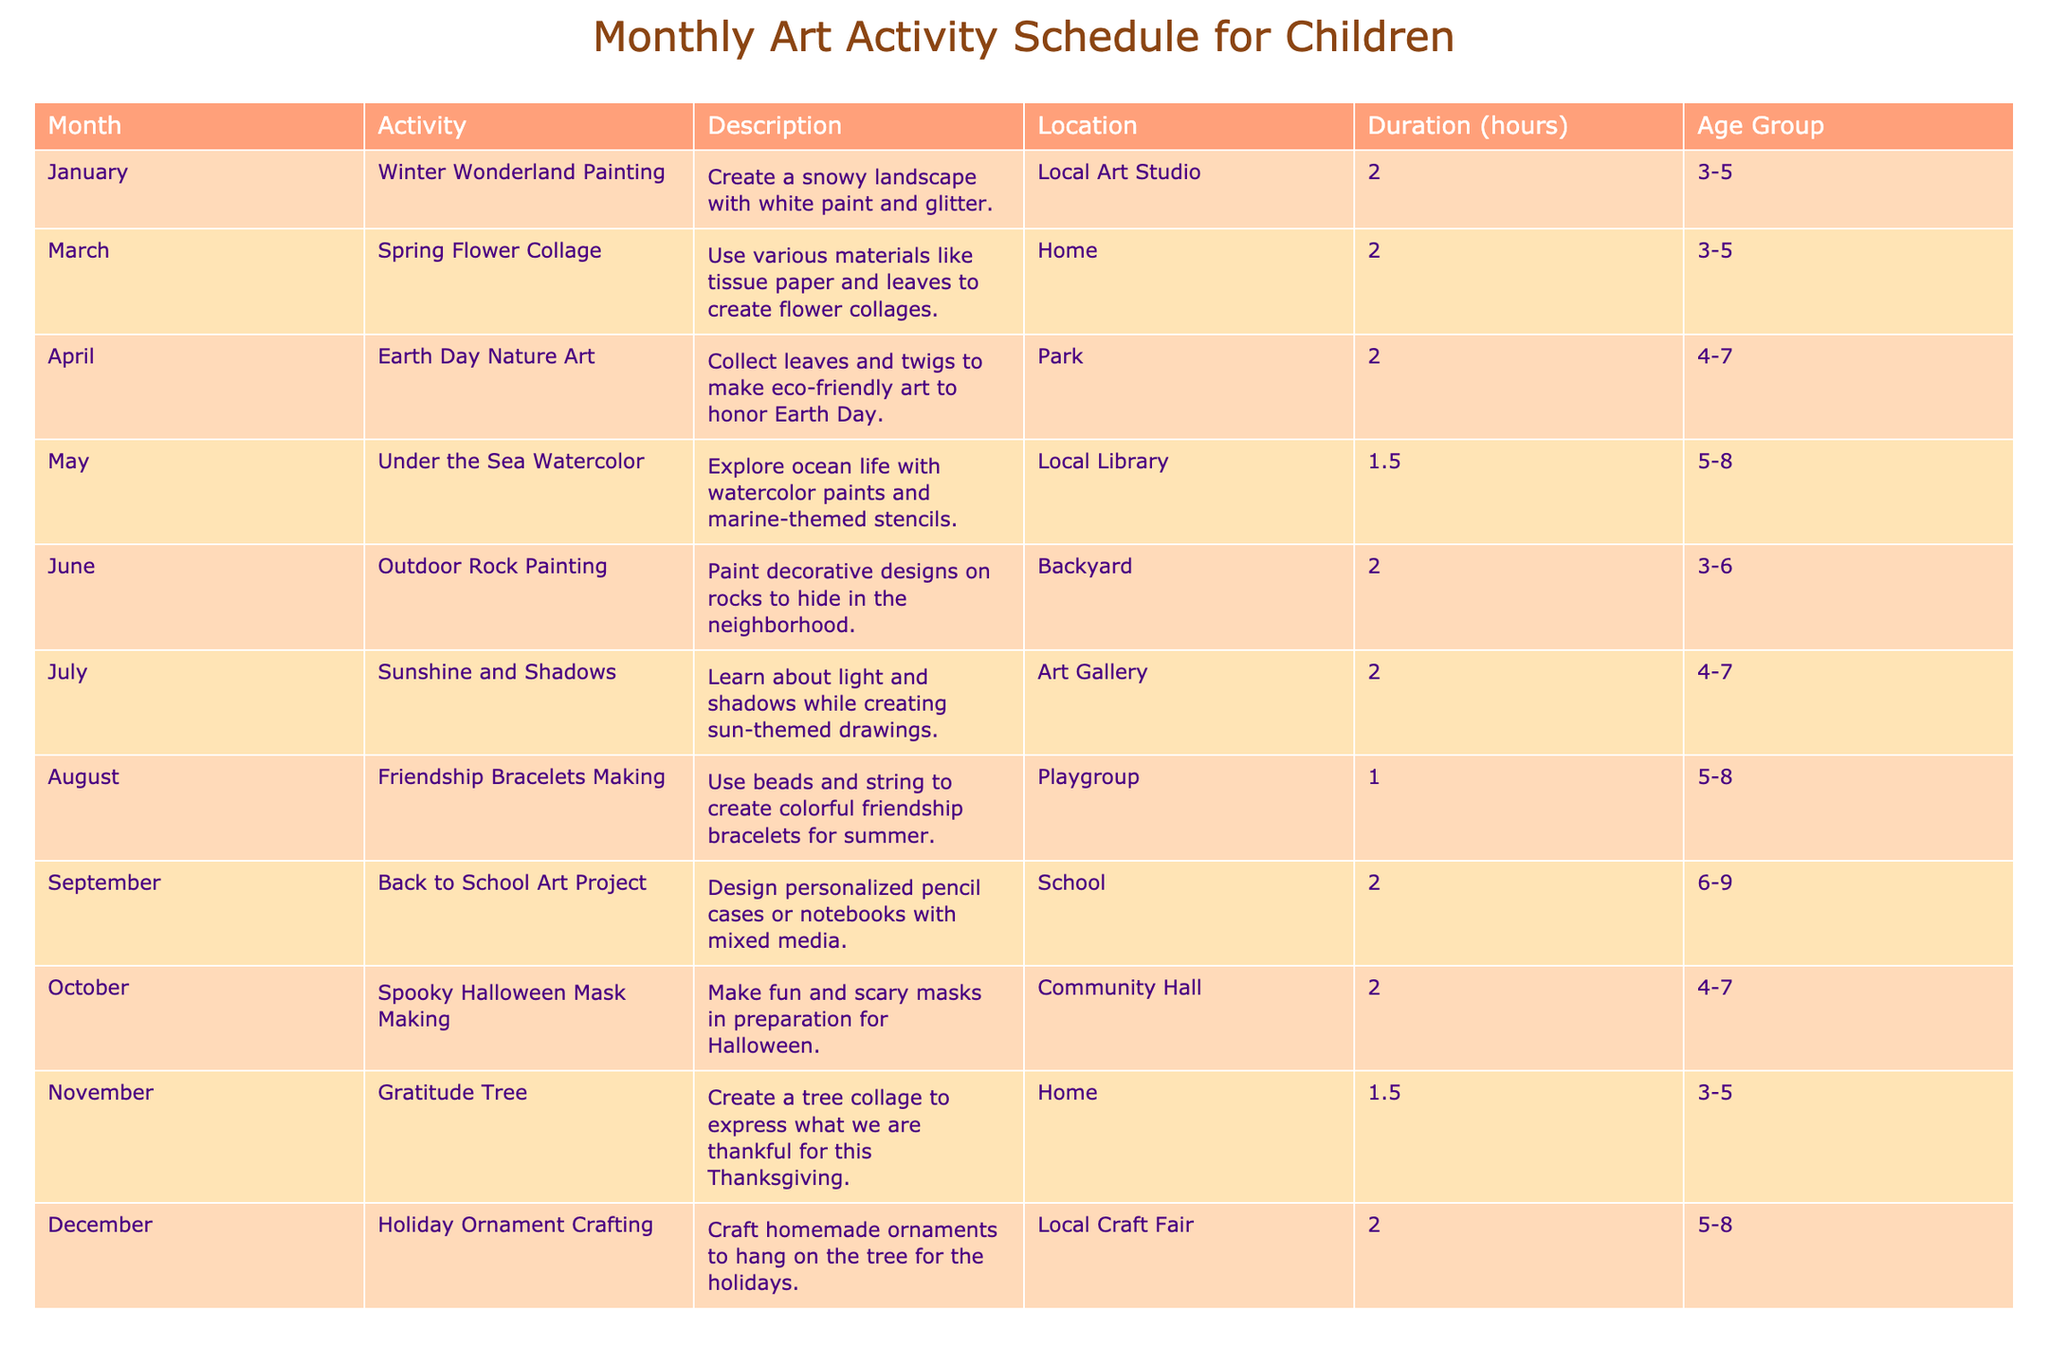What is the longest activity duration scheduled for children? The table shows the duration for each activity. Scanning the "Duration (hours)" column, I identify that the maximum duration appears to be 2 hours for multiple activities, specifically in January, April, June, July, October, and December.
Answer: 2 hours In which month would a child aged 4-7 participate in outdoor art activity? Looking at the age group for the outdoor activity, "Outdoor Rock Painting" in June allows children aged 3-6, while "Earth Day Nature Art" in April allows ages 4-7. Therefore, April is suitable for the specified age group involving an outdoor activity.
Answer: April Which activity takes place in the Local Library? By scanning through the "Location" column, I find that the "Under the Sea Watercolor" activity is conducted in the Local Library, which is listed in May.
Answer: Under the Sea Watercolor Count the number of activities suitable for ages 3-5. I review the "Age Group" column for activities that cater to the 3-5 age group. The activities that fit this category are in January, March, June, November, making a total of four activities.
Answer: 4 Is there an art activity scheduled during the summer months? Examining the list of months, I see activities scheduled in June (Outdoor Rock Painting) and July (Sunshine and Shadows). Therefore, yes, there are activities during the summer months.
Answer: Yes What is the average duration of all activities in the schedule? First, I sum the durations: 2 + 2 + 2 + 1.5 + 2 + 2 + 1 + 2 + 2 + 2 + 1.5 + 2 = 24 hours for 12 activities. Dividing the total duration by the number of activities gives me 24/12 = 2 hours on average.
Answer: 2 hours Which activity focuses on giving thanks, and when is it held? The "Gratitude Tree" activity is specifically designed to express thankfulness. Upon checking the schedule, it is held in November.
Answer: Gratitude Tree, November What is the total number of unique locations for the activities listed? After reviewing the "Location" column, I identify four unique places: Local Art Studio, Home, Park, Local Library, Backyard, Art Gallery, Playgroup, School, Community Hall, and Local Craft Fair. This gives a total of ten distinct locations.
Answer: 10 Which month has the most activities for the age group 5-8? Scanning the table, the activities for the age group 5-8 occur in May (Under the Sea Watercolor), August (Friendship Bracelets Making), and December (Holiday Ornament Crafting). Strikingly, three activities are focused on this age group across these months, making August the month with the most activities.
Answer: August 